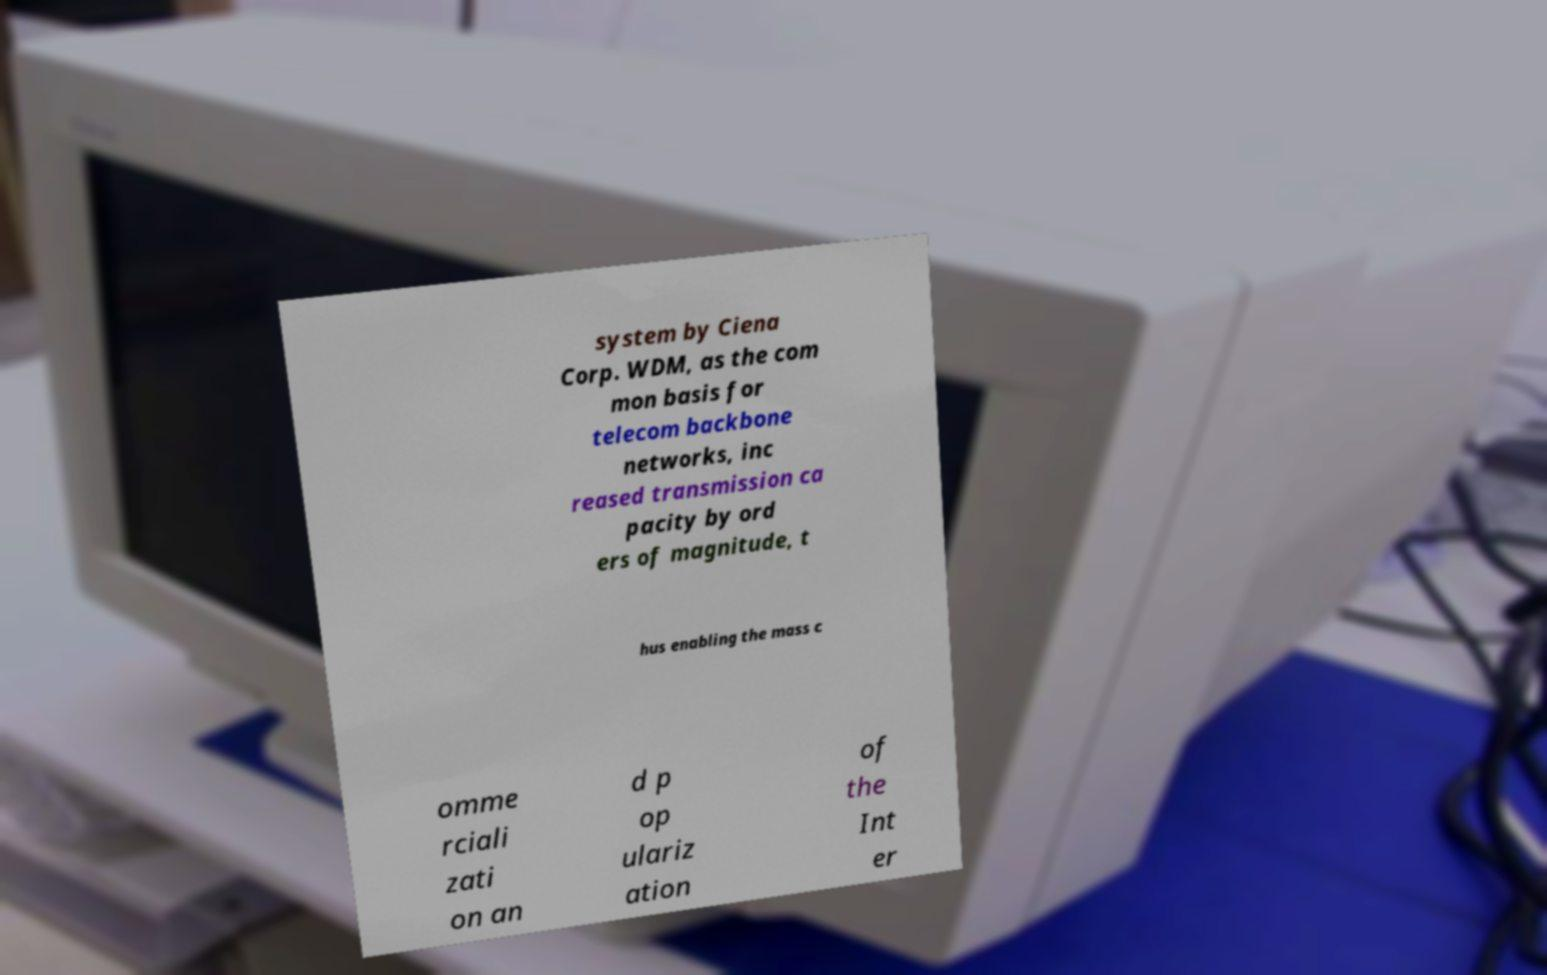What messages or text are displayed in this image? I need them in a readable, typed format. system by Ciena Corp. WDM, as the com mon basis for telecom backbone networks, inc reased transmission ca pacity by ord ers of magnitude, t hus enabling the mass c omme rciali zati on an d p op ulariz ation of the Int er 